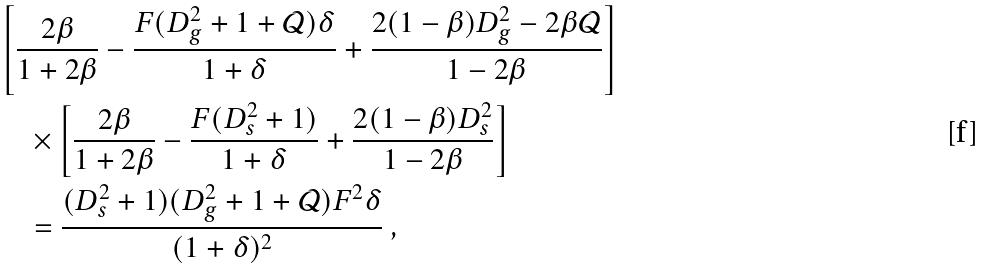<formula> <loc_0><loc_0><loc_500><loc_500>& \left [ \frac { 2 \beta } { 1 + 2 \beta } - \frac { F ( D _ { g } ^ { 2 } + 1 + \mathcal { Q } ) \delta } { 1 + \delta } + \frac { 2 ( 1 - \beta ) D _ { g } ^ { 2 } - 2 \beta \mathcal { Q } } { 1 - 2 \beta } \right ] \\ & \quad \times \left [ \frac { 2 \beta } { 1 + 2 \beta } - \frac { F ( D _ { s } ^ { 2 } + 1 ) } { 1 + \delta } + \frac { 2 ( 1 - \beta ) D _ { s } ^ { 2 } } { 1 - 2 \beta } \right ] \\ & \quad = \frac { ( D _ { s } ^ { 2 } + 1 ) ( D _ { g } ^ { 2 } + 1 + \mathcal { Q } ) F ^ { 2 } \delta } { ( 1 + \delta ) ^ { 2 } } \ ,</formula> 